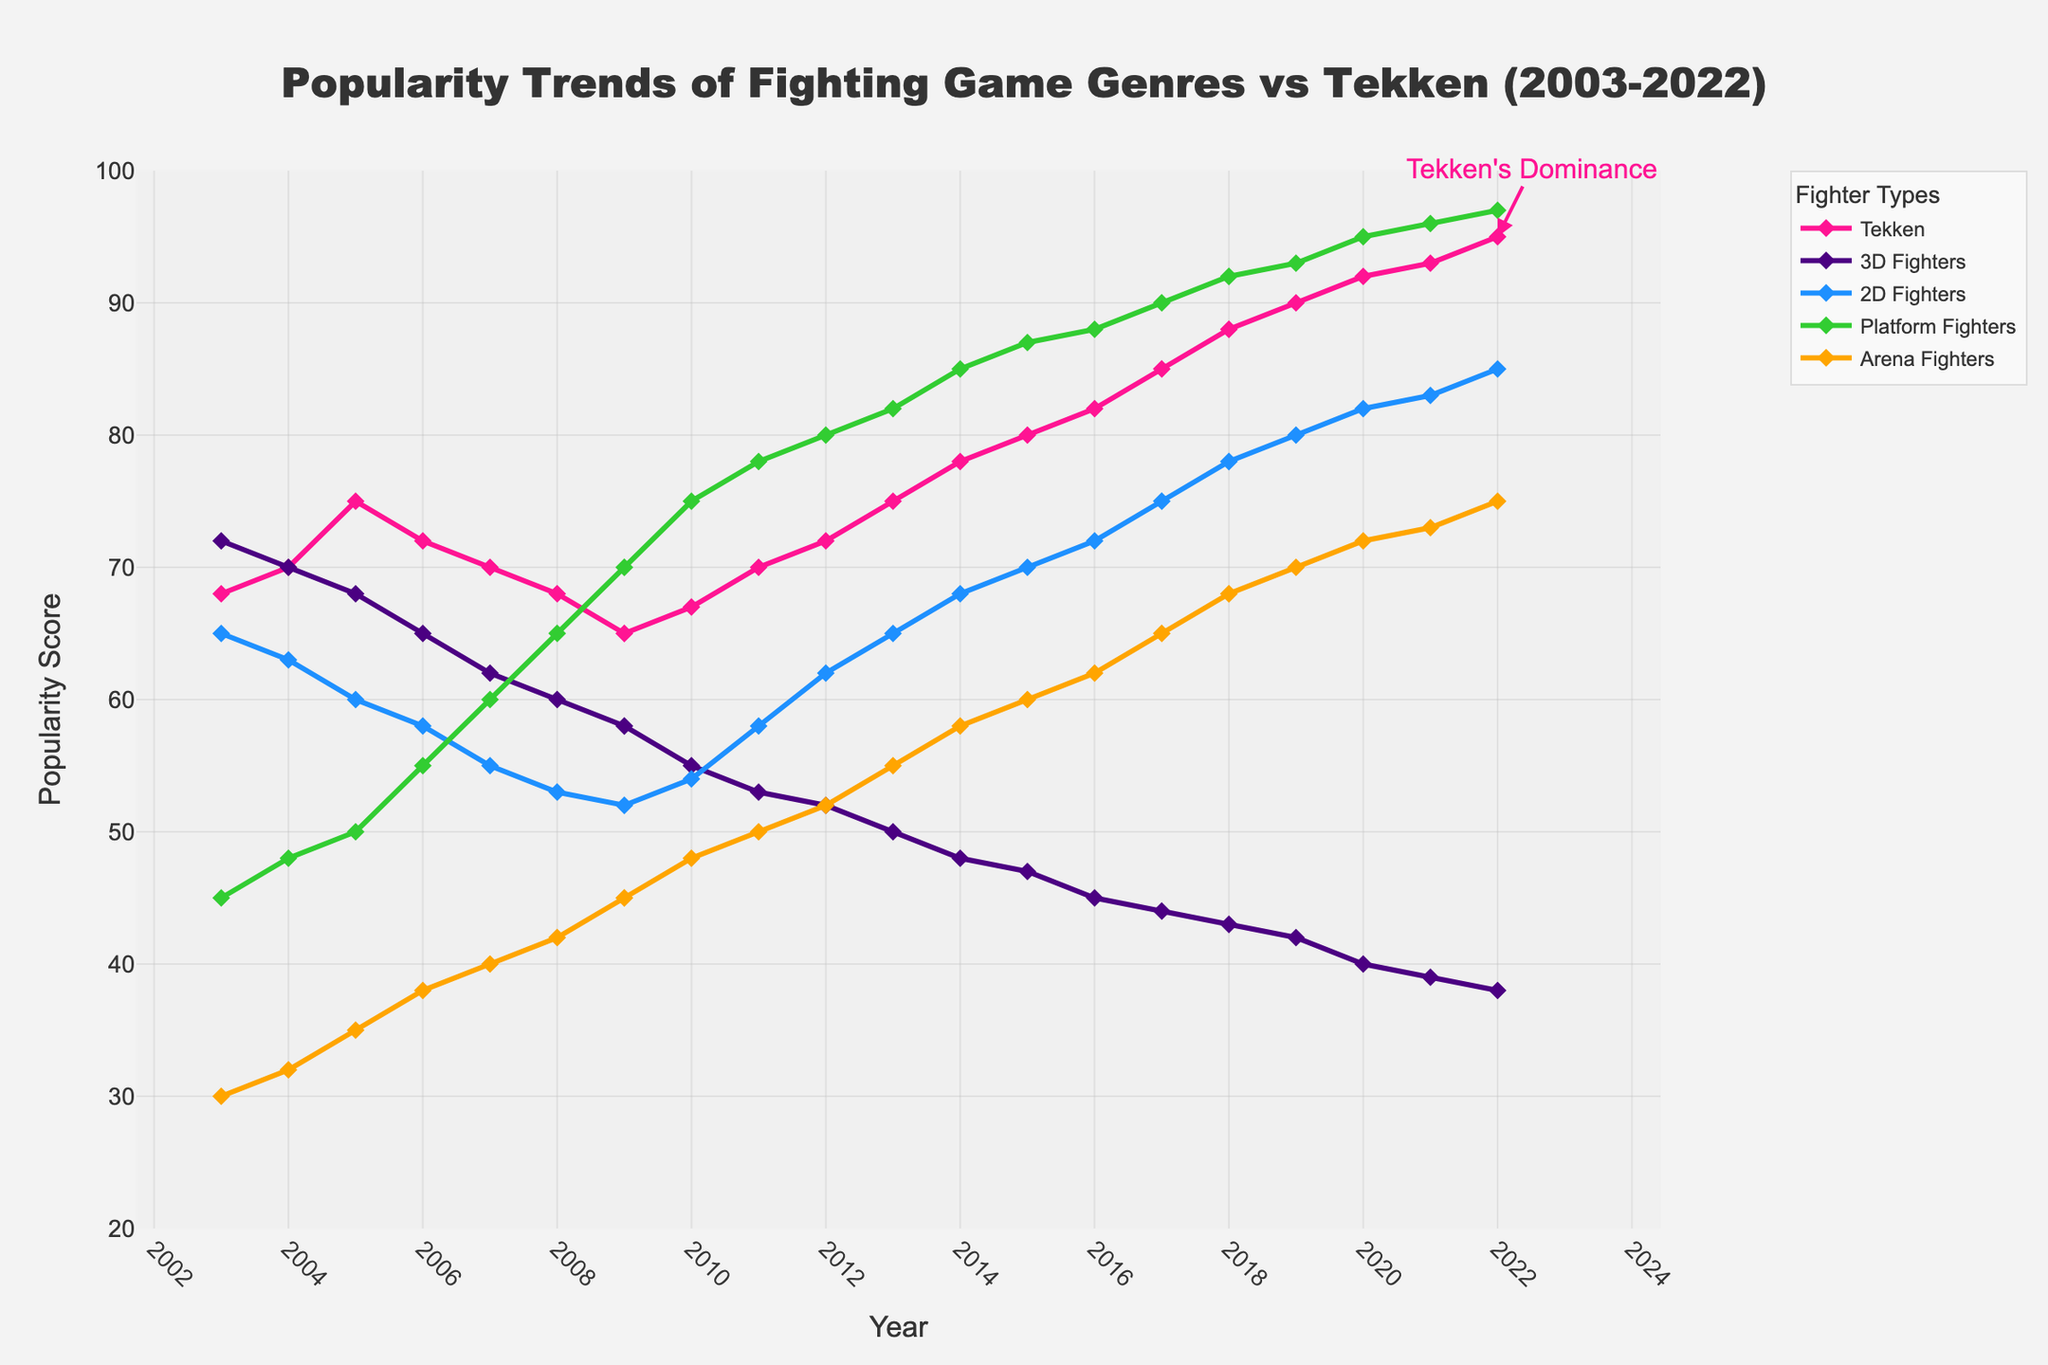what is the trend of Tekken's popularity from 2003 to 2022? The trend of Tekken's popularity can be observed by looking at the points and connecting lines in the plot. From 2003 to 2022, the points representing Tekken rise progressively. The general direction of the line moves upward, showing an increase in popularity over the years.
Answer: Increasing Which year marked the peak popularity for 2D Fighters? To identify the peak popularity for 2D Fighters, look for the point on the plot where the 2D Fighters line reaches its highest value. This occurs in 2022 with a popularity score of 85.
Answer: 2022 By how much did Platform Fighters' popularity increase between 2003 and 2022? To find the increase, subtract the initial popularity score (45 in 2003) from the final popularity score (97 in 2022) for Platform Fighters: 97 - 45 = 52.
Answer: 52 points Compare the popularity scores of Tekken and Platform Fighters in 2010. Which was more popular and by how much? First, look at the values for both categories in 2010: Tekken (67) and Platform Fighters (75). Compare them: Platform Fighters are more popular by 75 - 67 = 8 points.
Answer: Platform Fighters by 8 points What trends can be observed for 3D Fighters from 2003 to 2022? The 3D Fighters line starts at a high value of 72 in 2003 and gradually decreases over the years. The line moves downward consistently, indicating a steady decline in popularity from 2003 to 2022.
Answer: Declining In which year did Arena Fighters surpass the popularity score of 60? Identify when the Arena Fighters line crosses the value of 60. According to the plot, this happens around 2013 when it reaches 55 and then 58 in 2014, and finally surpasses 60 in 2015 (score: 60).
Answer: 2015 Compare the popularity trends between Tekken and 2D Fighters over the range of available years. Both Tekken and 2D Fighters show upward trends, but Tekken's rise is steadier and more consistent. 2D Fighters have more fluctuation yet still generally increase. Overall, Tekken's popularity increases more rapidly.
Answer: Both increase, Tekken more steadily What is the lowest popularity score recorded for Arena Fighters from 2003 to 2022? To find the lowest score, look for the minimum point on the Arena Fighters line. In 2003, the score is 30, which is the lowest throughout the dataset.
Answer: 30 Calculate the average popularity score of Tekken over the given years. Sum up Tekken's popularity scores from 2003 to 2022 and then divide by the number of years (20): (68 + 70 + 75 + 72 + 70 + 68 + 65 + 67 + 70 + 72 + 75 + 78 + 80 + 82 + 85 + 88 + 90 + 92 + 93 + 95) / 20 = 77.7.
Answer: 77.7 